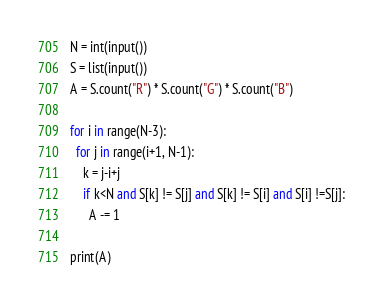<code> <loc_0><loc_0><loc_500><loc_500><_Python_>N = int(input())
S = list(input())
A = S.count("R") * S.count("G") * S.count("B")

for i in range(N-3):
  for j in range(i+1, N-1):
    k = j-i+j
    if k<N and S[k] != S[j] and S[k] != S[i] and S[i] !=S[j]:
      A -= 1

print(A)
</code> 